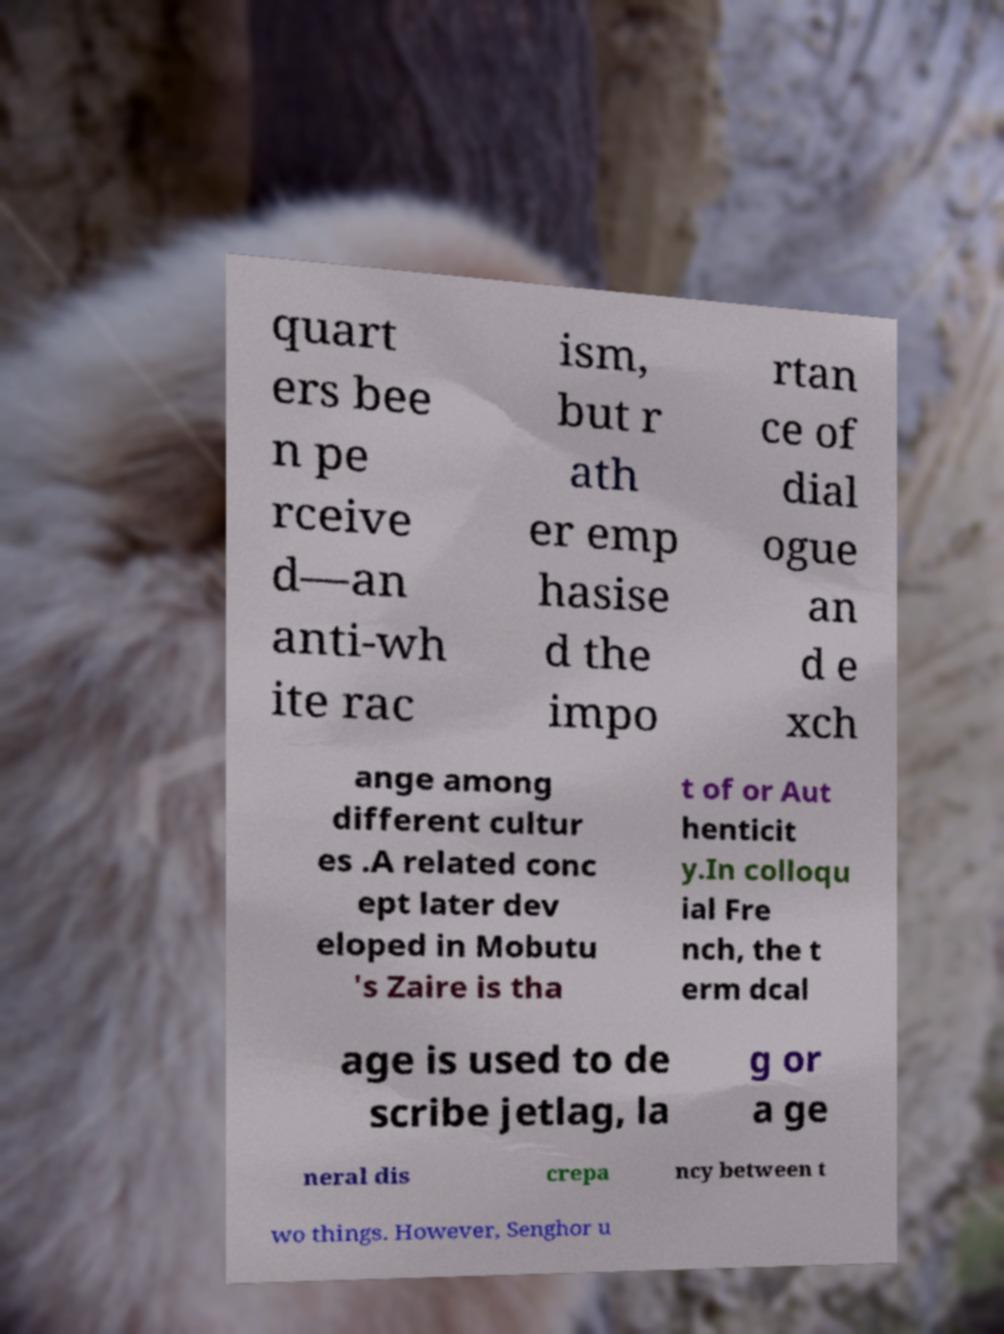Please read and relay the text visible in this image. What does it say? quart ers bee n pe rceive d—an anti-wh ite rac ism, but r ath er emp hasise d the impo rtan ce of dial ogue an d e xch ange among different cultur es .A related conc ept later dev eloped in Mobutu 's Zaire is tha t of or Aut henticit y.In colloqu ial Fre nch, the t erm dcal age is used to de scribe jetlag, la g or a ge neral dis crepa ncy between t wo things. However, Senghor u 